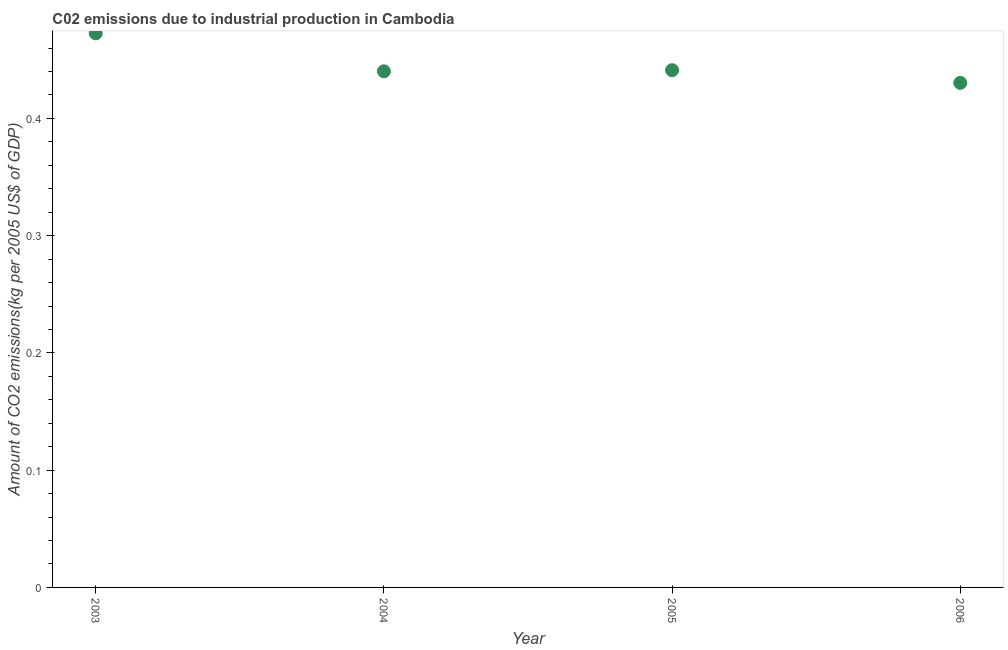What is the amount of co2 emissions in 2005?
Your answer should be very brief. 0.44. Across all years, what is the maximum amount of co2 emissions?
Offer a very short reply. 0.47. Across all years, what is the minimum amount of co2 emissions?
Your response must be concise. 0.43. What is the sum of the amount of co2 emissions?
Your response must be concise. 1.78. What is the difference between the amount of co2 emissions in 2005 and 2006?
Ensure brevity in your answer.  0.01. What is the average amount of co2 emissions per year?
Keep it short and to the point. 0.45. What is the median amount of co2 emissions?
Give a very brief answer. 0.44. In how many years, is the amount of co2 emissions greater than 0.32000000000000006 kg per 2005 US$ of GDP?
Your answer should be very brief. 4. Do a majority of the years between 2003 and 2005 (inclusive) have amount of co2 emissions greater than 0.02 kg per 2005 US$ of GDP?
Your response must be concise. Yes. What is the ratio of the amount of co2 emissions in 2005 to that in 2006?
Your answer should be compact. 1.03. Is the amount of co2 emissions in 2003 less than that in 2005?
Keep it short and to the point. No. Is the difference between the amount of co2 emissions in 2003 and 2006 greater than the difference between any two years?
Offer a very short reply. Yes. What is the difference between the highest and the second highest amount of co2 emissions?
Keep it short and to the point. 0.03. Is the sum of the amount of co2 emissions in 2003 and 2005 greater than the maximum amount of co2 emissions across all years?
Provide a short and direct response. Yes. What is the difference between the highest and the lowest amount of co2 emissions?
Ensure brevity in your answer.  0.04. In how many years, is the amount of co2 emissions greater than the average amount of co2 emissions taken over all years?
Your answer should be compact. 1. Does the amount of co2 emissions monotonically increase over the years?
Provide a short and direct response. No. How many dotlines are there?
Provide a short and direct response. 1. How many years are there in the graph?
Make the answer very short. 4. Does the graph contain grids?
Ensure brevity in your answer.  No. What is the title of the graph?
Make the answer very short. C02 emissions due to industrial production in Cambodia. What is the label or title of the X-axis?
Provide a succinct answer. Year. What is the label or title of the Y-axis?
Give a very brief answer. Amount of CO2 emissions(kg per 2005 US$ of GDP). What is the Amount of CO2 emissions(kg per 2005 US$ of GDP) in 2003?
Offer a very short reply. 0.47. What is the Amount of CO2 emissions(kg per 2005 US$ of GDP) in 2004?
Offer a very short reply. 0.44. What is the Amount of CO2 emissions(kg per 2005 US$ of GDP) in 2005?
Give a very brief answer. 0.44. What is the Amount of CO2 emissions(kg per 2005 US$ of GDP) in 2006?
Offer a terse response. 0.43. What is the difference between the Amount of CO2 emissions(kg per 2005 US$ of GDP) in 2003 and 2004?
Provide a succinct answer. 0.03. What is the difference between the Amount of CO2 emissions(kg per 2005 US$ of GDP) in 2003 and 2005?
Your answer should be compact. 0.03. What is the difference between the Amount of CO2 emissions(kg per 2005 US$ of GDP) in 2003 and 2006?
Offer a terse response. 0.04. What is the difference between the Amount of CO2 emissions(kg per 2005 US$ of GDP) in 2004 and 2005?
Offer a very short reply. -0. What is the difference between the Amount of CO2 emissions(kg per 2005 US$ of GDP) in 2004 and 2006?
Provide a short and direct response. 0.01. What is the difference between the Amount of CO2 emissions(kg per 2005 US$ of GDP) in 2005 and 2006?
Your answer should be compact. 0.01. What is the ratio of the Amount of CO2 emissions(kg per 2005 US$ of GDP) in 2003 to that in 2004?
Your answer should be very brief. 1.07. What is the ratio of the Amount of CO2 emissions(kg per 2005 US$ of GDP) in 2003 to that in 2005?
Make the answer very short. 1.07. What is the ratio of the Amount of CO2 emissions(kg per 2005 US$ of GDP) in 2003 to that in 2006?
Provide a succinct answer. 1.1. What is the ratio of the Amount of CO2 emissions(kg per 2005 US$ of GDP) in 2004 to that in 2005?
Provide a succinct answer. 1. What is the ratio of the Amount of CO2 emissions(kg per 2005 US$ of GDP) in 2004 to that in 2006?
Offer a very short reply. 1.02. What is the ratio of the Amount of CO2 emissions(kg per 2005 US$ of GDP) in 2005 to that in 2006?
Make the answer very short. 1.02. 